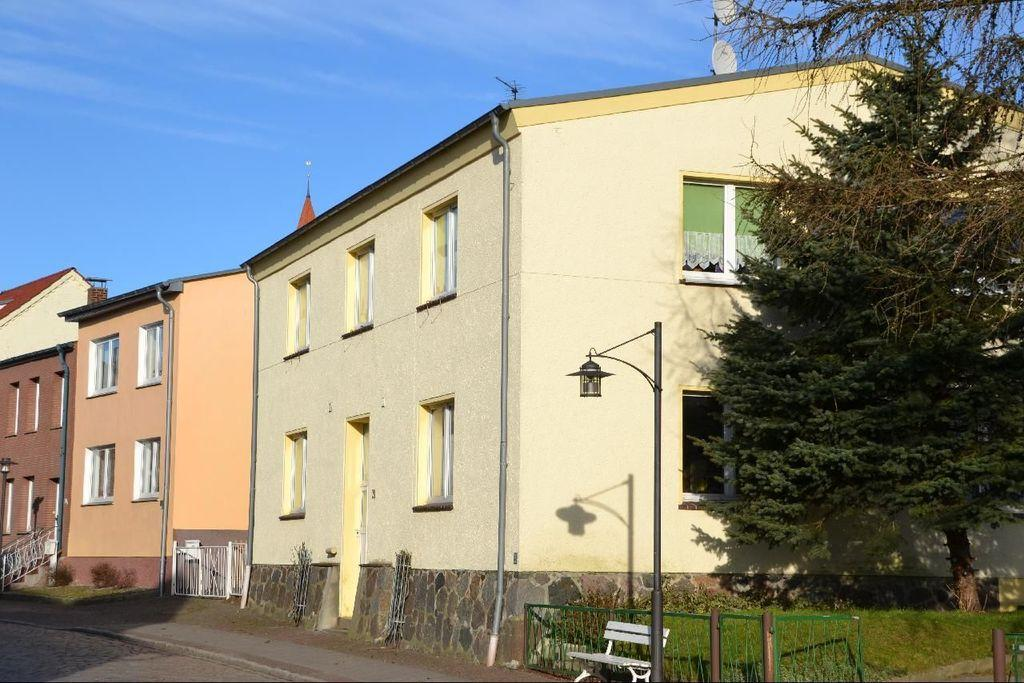What type of structures can be seen in the image? There are buildings in the image. What type of vegetation is on the right side of the image? There is a tree on the right side of the image. What is located in front of the fencing in the image? There is a bench and a pole in front of the fencing. What is visible at the top of the image? The sky is visible at the top of the image. What type of toys are scattered around the buildings in the image? There are no toys present in the image; it features buildings, a tree, a bench, a pole, and the sky. 